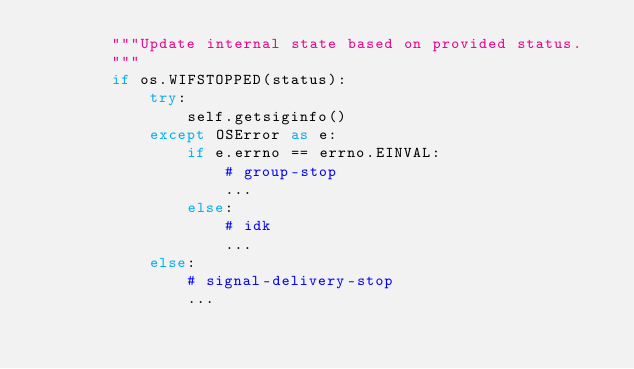Convert code to text. <code><loc_0><loc_0><loc_500><loc_500><_Python_>        """Update internal state based on provided status.
        """
        if os.WIFSTOPPED(status):
            try:
                self.getsiginfo()
            except OSError as e:
                if e.errno == errno.EINVAL:
                    # group-stop
                    ...
                else:
                    # idk
                    ...
            else:
                # signal-delivery-stop
                ...
</code> 